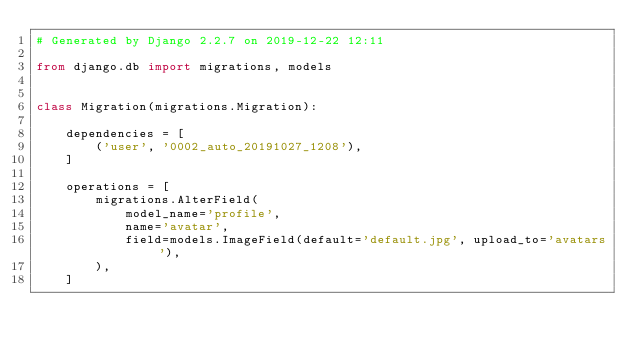<code> <loc_0><loc_0><loc_500><loc_500><_Python_># Generated by Django 2.2.7 on 2019-12-22 12:11

from django.db import migrations, models


class Migration(migrations.Migration):

    dependencies = [
        ('user', '0002_auto_20191027_1208'),
    ]

    operations = [
        migrations.AlterField(
            model_name='profile',
            name='avatar',
            field=models.ImageField(default='default.jpg', upload_to='avatars'),
        ),
    ]
</code> 